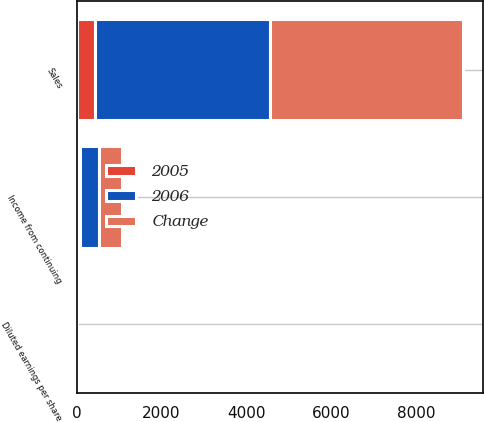<chart> <loc_0><loc_0><loc_500><loc_500><stacked_bar_chart><ecel><fcel>Sales<fcel>Income from continuing<fcel>Diluted earnings per share<nl><fcel>Change<fcel>4556.4<fcel>529.3<fcel>2.94<nl><fcel>2006<fcel>4111.5<fcel>447.7<fcel>2.39<nl><fcel>2005<fcel>444.9<fcel>81.6<fcel>0.55<nl></chart> 